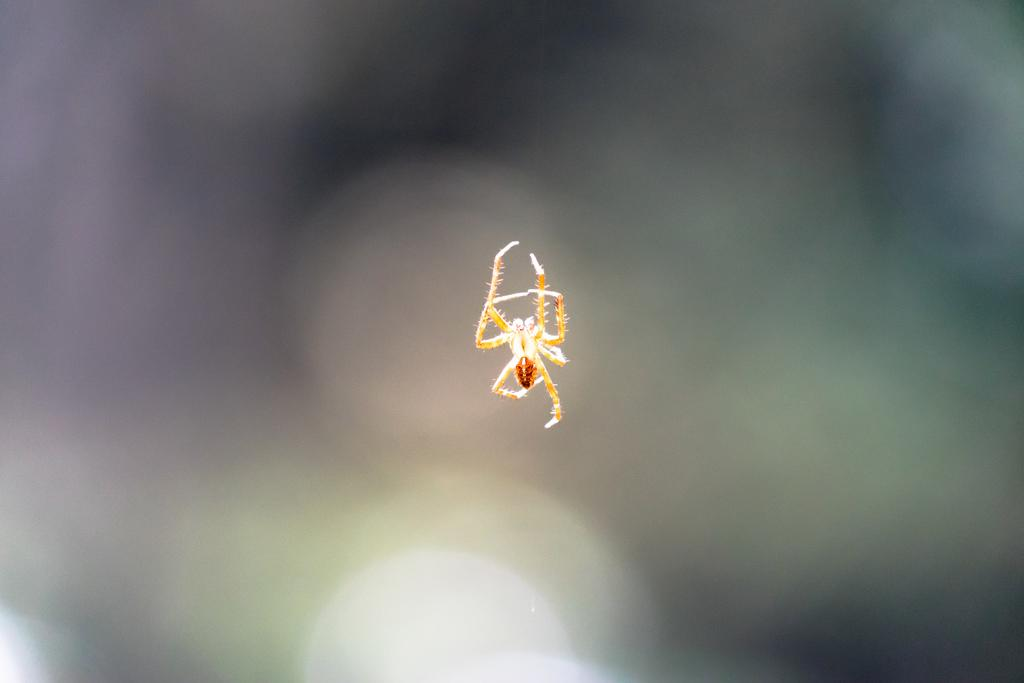What is the main subject of the image? There is a spider in the image. Can you describe the background of the image? The background of the image is blurred. How much sugar is in the tin located in the camp in the image? There is no tin or camp present in the image; it only features a spider with a blurred background. 